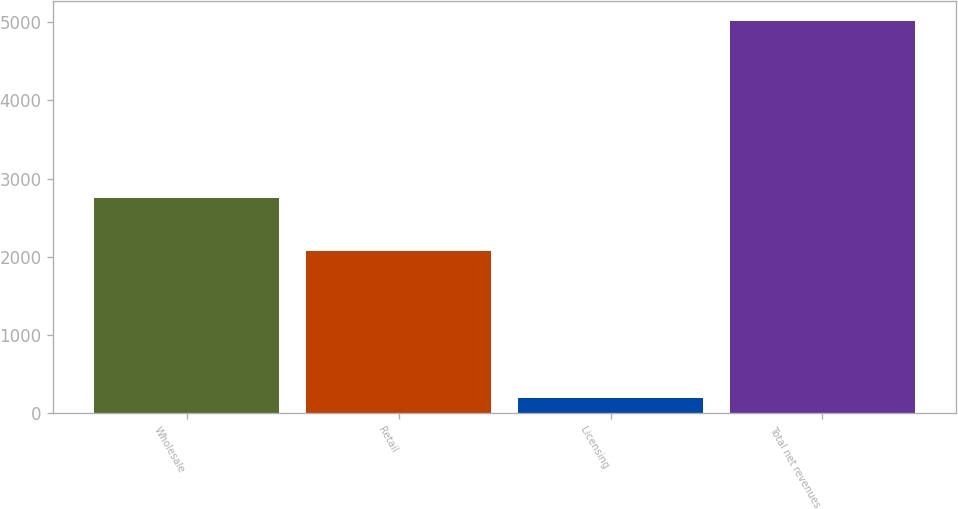Convert chart to OTSL. <chart><loc_0><loc_0><loc_500><loc_500><bar_chart><fcel>Wholesale<fcel>Retail<fcel>Licensing<fcel>Total net revenues<nl><fcel>2749.5<fcel>2074.2<fcel>195.2<fcel>5018.9<nl></chart> 